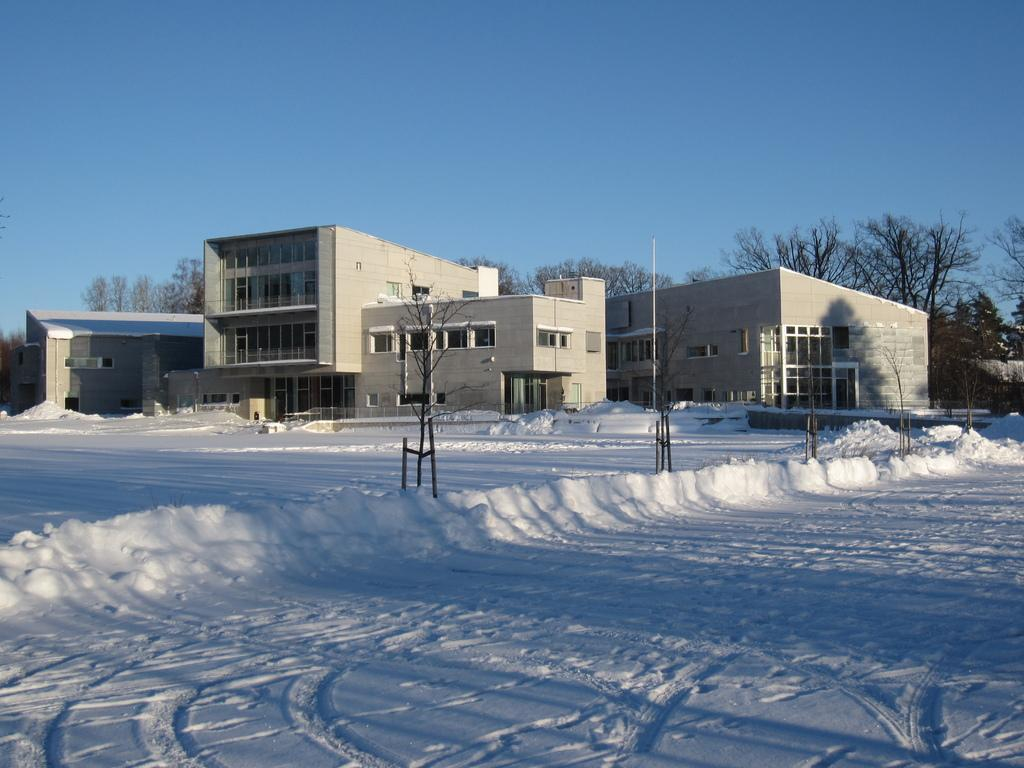What type of structures can be seen in the image? There are buildings in the image. What is located in front of the buildings? There are trees and a pole in front of the buildings. Are there any other trees visible in the image? Yes, there are groups of trees behind the buildings. What is visible at the top of the image? The sky is visible at the top of the image. Can you tell me how many geese are playing chess in the image? There are no geese or chess games present in the image. What is the emotion of the buildings in the image? Buildings do not have emotions; they are inanimate objects. 